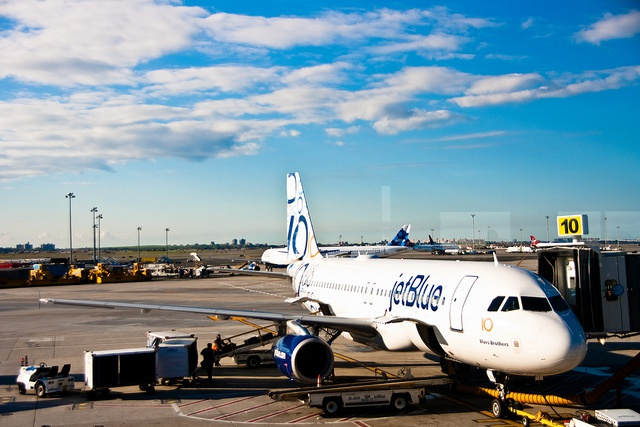Describe the objects in this image and their specific colors. I can see airplane in lightgray, white, black, darkgray, and gray tones, truck in lightgray, black, white, tan, and gray tones, airplane in lightgray, white, darkgray, gray, and black tones, people in lightgray, black, tan, and maroon tones, and airplane in lightgray, blue, darkgray, gray, and black tones in this image. 